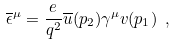Convert formula to latex. <formula><loc_0><loc_0><loc_500><loc_500>\overline { \epsilon } ^ { \mu } = \frac { e } { q ^ { 2 } } \overline { u } ( p _ { 2 } ) \gamma ^ { \mu } v ( p _ { 1 } ) \ ,</formula> 